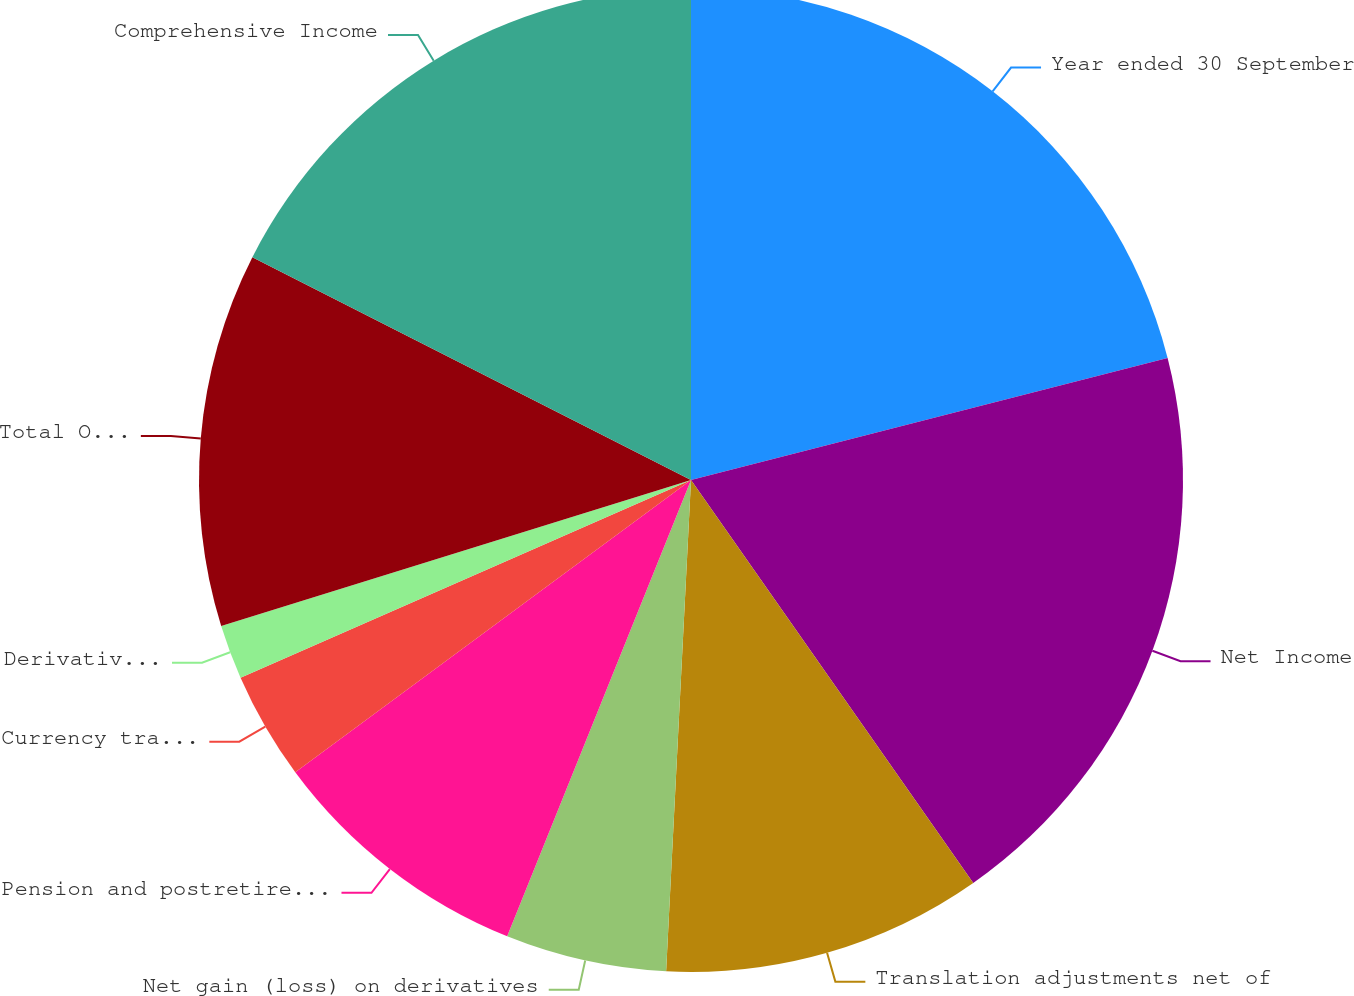Convert chart. <chart><loc_0><loc_0><loc_500><loc_500><pie_chart><fcel>Year ended 30 September<fcel>Net Income<fcel>Translation adjustments net of<fcel>Net gain (loss) on derivatives<fcel>Pension and postretirement<fcel>Currency translation<fcel>Derivatives net of tax of (55)<fcel>Total Other Comprehensive<fcel>Comprehensive Income<nl><fcel>21.01%<fcel>19.27%<fcel>10.53%<fcel>5.29%<fcel>8.78%<fcel>3.54%<fcel>1.79%<fcel>12.28%<fcel>17.52%<nl></chart> 